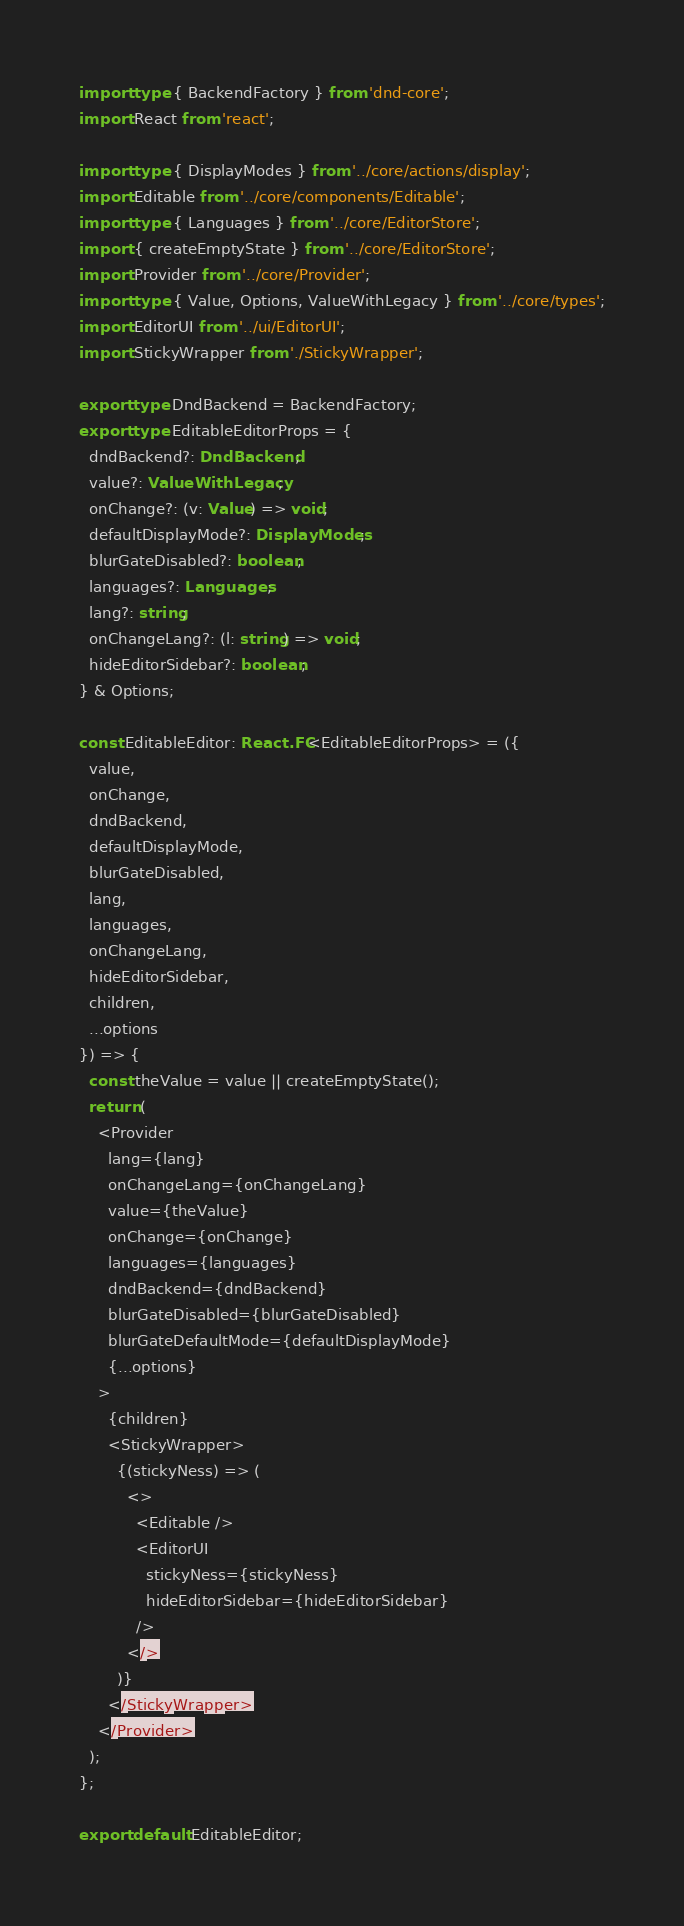<code> <loc_0><loc_0><loc_500><loc_500><_TypeScript_>import type { BackendFactory } from 'dnd-core';
import React from 'react';

import type { DisplayModes } from '../core/actions/display';
import Editable from '../core/components/Editable';
import type { Languages } from '../core/EditorStore';
import { createEmptyState } from '../core/EditorStore';
import Provider from '../core/Provider';
import type { Value, Options, ValueWithLegacy } from '../core/types';
import EditorUI from '../ui/EditorUI';
import StickyWrapper from './StickyWrapper';

export type DndBackend = BackendFactory;
export type EditableEditorProps = {
  dndBackend?: DndBackend;
  value?: ValueWithLegacy;
  onChange?: (v: Value) => void;
  defaultDisplayMode?: DisplayModes;
  blurGateDisabled?: boolean;
  languages?: Languages;
  lang?: string;
  onChangeLang?: (l: string) => void;
  hideEditorSidebar?: boolean;
} & Options;

const EditableEditor: React.FC<EditableEditorProps> = ({
  value,
  onChange,
  dndBackend,
  defaultDisplayMode,
  blurGateDisabled,
  lang,
  languages,
  onChangeLang,
  hideEditorSidebar,
  children,
  ...options
}) => {
  const theValue = value || createEmptyState();
  return (
    <Provider
      lang={lang}
      onChangeLang={onChangeLang}
      value={theValue}
      onChange={onChange}
      languages={languages}
      dndBackend={dndBackend}
      blurGateDisabled={blurGateDisabled}
      blurGateDefaultMode={defaultDisplayMode}
      {...options}
    >
      {children}
      <StickyWrapper>
        {(stickyNess) => (
          <>
            <Editable />
            <EditorUI
              stickyNess={stickyNess}
              hideEditorSidebar={hideEditorSidebar}
            />
          </>
        )}
      </StickyWrapper>
    </Provider>
  );
};

export default EditableEditor;
</code> 